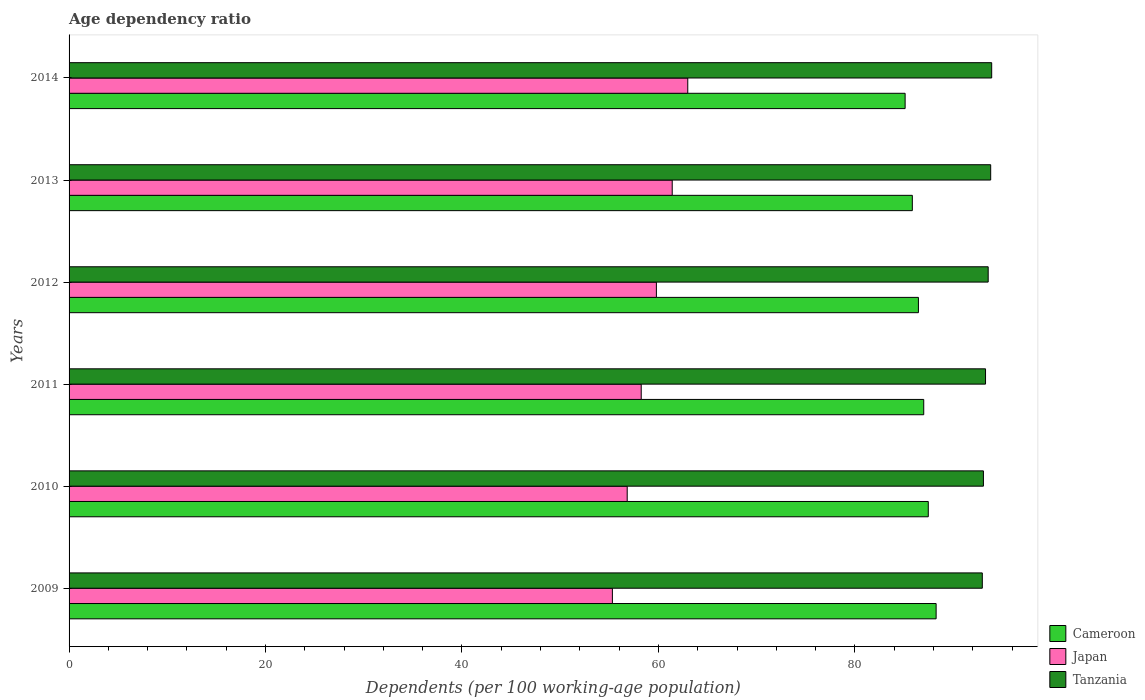How many groups of bars are there?
Offer a very short reply. 6. Are the number of bars per tick equal to the number of legend labels?
Keep it short and to the point. Yes. What is the age dependency ratio in in Cameroon in 2010?
Give a very brief answer. 87.47. Across all years, what is the maximum age dependency ratio in in Cameroon?
Make the answer very short. 88.27. Across all years, what is the minimum age dependency ratio in in Japan?
Ensure brevity in your answer.  55.31. In which year was the age dependency ratio in in Cameroon maximum?
Provide a short and direct response. 2009. What is the total age dependency ratio in in Japan in the graph?
Your response must be concise. 354.55. What is the difference between the age dependency ratio in in Cameroon in 2011 and that in 2012?
Your answer should be very brief. 0.54. What is the difference between the age dependency ratio in in Japan in 2010 and the age dependency ratio in in Cameroon in 2012?
Offer a very short reply. -29.65. What is the average age dependency ratio in in Japan per year?
Offer a terse response. 59.09. In the year 2014, what is the difference between the age dependency ratio in in Cameroon and age dependency ratio in in Japan?
Offer a terse response. 22.13. What is the ratio of the age dependency ratio in in Cameroon in 2009 to that in 2014?
Your answer should be compact. 1.04. Is the difference between the age dependency ratio in in Cameroon in 2012 and 2014 greater than the difference between the age dependency ratio in in Japan in 2012 and 2014?
Provide a short and direct response. Yes. What is the difference between the highest and the second highest age dependency ratio in in Japan?
Provide a short and direct response. 1.58. What is the difference between the highest and the lowest age dependency ratio in in Tanzania?
Give a very brief answer. 0.95. In how many years, is the age dependency ratio in in Japan greater than the average age dependency ratio in in Japan taken over all years?
Ensure brevity in your answer.  3. Is the sum of the age dependency ratio in in Japan in 2009 and 2011 greater than the maximum age dependency ratio in in Cameroon across all years?
Your answer should be compact. Yes. What does the 1st bar from the top in 2009 represents?
Make the answer very short. Tanzania. What does the 3rd bar from the bottom in 2010 represents?
Keep it short and to the point. Tanzania. How many bars are there?
Ensure brevity in your answer.  18. Are all the bars in the graph horizontal?
Provide a succinct answer. Yes. How many years are there in the graph?
Your answer should be very brief. 6. Does the graph contain grids?
Offer a terse response. No. How are the legend labels stacked?
Give a very brief answer. Vertical. What is the title of the graph?
Provide a succinct answer. Age dependency ratio. Does "Finland" appear as one of the legend labels in the graph?
Ensure brevity in your answer.  No. What is the label or title of the X-axis?
Ensure brevity in your answer.  Dependents (per 100 working-age population). What is the Dependents (per 100 working-age population) in Cameroon in 2009?
Offer a terse response. 88.27. What is the Dependents (per 100 working-age population) of Japan in 2009?
Ensure brevity in your answer.  55.31. What is the Dependents (per 100 working-age population) in Tanzania in 2009?
Your answer should be compact. 92.97. What is the Dependents (per 100 working-age population) of Cameroon in 2010?
Your answer should be compact. 87.47. What is the Dependents (per 100 working-age population) of Japan in 2010?
Your response must be concise. 56.82. What is the Dependents (per 100 working-age population) of Tanzania in 2010?
Your response must be concise. 93.08. What is the Dependents (per 100 working-age population) in Cameroon in 2011?
Your response must be concise. 87.01. What is the Dependents (per 100 working-age population) in Japan in 2011?
Provide a succinct answer. 58.24. What is the Dependents (per 100 working-age population) in Tanzania in 2011?
Give a very brief answer. 93.3. What is the Dependents (per 100 working-age population) in Cameroon in 2012?
Your answer should be compact. 86.47. What is the Dependents (per 100 working-age population) in Japan in 2012?
Keep it short and to the point. 59.79. What is the Dependents (per 100 working-age population) in Tanzania in 2012?
Your answer should be very brief. 93.57. What is the Dependents (per 100 working-age population) of Cameroon in 2013?
Keep it short and to the point. 85.84. What is the Dependents (per 100 working-age population) in Japan in 2013?
Provide a short and direct response. 61.4. What is the Dependents (per 100 working-age population) in Tanzania in 2013?
Offer a very short reply. 93.82. What is the Dependents (per 100 working-age population) in Cameroon in 2014?
Provide a succinct answer. 85.11. What is the Dependents (per 100 working-age population) in Japan in 2014?
Make the answer very short. 62.98. What is the Dependents (per 100 working-age population) of Tanzania in 2014?
Provide a succinct answer. 93.92. Across all years, what is the maximum Dependents (per 100 working-age population) in Cameroon?
Offer a terse response. 88.27. Across all years, what is the maximum Dependents (per 100 working-age population) of Japan?
Make the answer very short. 62.98. Across all years, what is the maximum Dependents (per 100 working-age population) in Tanzania?
Your answer should be very brief. 93.92. Across all years, what is the minimum Dependents (per 100 working-age population) of Cameroon?
Your answer should be very brief. 85.11. Across all years, what is the minimum Dependents (per 100 working-age population) in Japan?
Your answer should be compact. 55.31. Across all years, what is the minimum Dependents (per 100 working-age population) of Tanzania?
Your answer should be very brief. 92.97. What is the total Dependents (per 100 working-age population) of Cameroon in the graph?
Offer a very short reply. 520.17. What is the total Dependents (per 100 working-age population) of Japan in the graph?
Offer a very short reply. 354.55. What is the total Dependents (per 100 working-age population) in Tanzania in the graph?
Ensure brevity in your answer.  560.66. What is the difference between the Dependents (per 100 working-age population) of Cameroon in 2009 and that in 2010?
Provide a short and direct response. 0.8. What is the difference between the Dependents (per 100 working-age population) in Japan in 2009 and that in 2010?
Your answer should be very brief. -1.51. What is the difference between the Dependents (per 100 working-age population) of Tanzania in 2009 and that in 2010?
Offer a very short reply. -0.11. What is the difference between the Dependents (per 100 working-age population) of Cameroon in 2009 and that in 2011?
Ensure brevity in your answer.  1.26. What is the difference between the Dependents (per 100 working-age population) of Japan in 2009 and that in 2011?
Give a very brief answer. -2.93. What is the difference between the Dependents (per 100 working-age population) of Tanzania in 2009 and that in 2011?
Keep it short and to the point. -0.33. What is the difference between the Dependents (per 100 working-age population) of Cameroon in 2009 and that in 2012?
Make the answer very short. 1.8. What is the difference between the Dependents (per 100 working-age population) of Japan in 2009 and that in 2012?
Give a very brief answer. -4.48. What is the difference between the Dependents (per 100 working-age population) of Tanzania in 2009 and that in 2012?
Give a very brief answer. -0.6. What is the difference between the Dependents (per 100 working-age population) of Cameroon in 2009 and that in 2013?
Your answer should be compact. 2.42. What is the difference between the Dependents (per 100 working-age population) in Japan in 2009 and that in 2013?
Offer a terse response. -6.09. What is the difference between the Dependents (per 100 working-age population) of Tanzania in 2009 and that in 2013?
Your response must be concise. -0.85. What is the difference between the Dependents (per 100 working-age population) in Cameroon in 2009 and that in 2014?
Ensure brevity in your answer.  3.16. What is the difference between the Dependents (per 100 working-age population) of Japan in 2009 and that in 2014?
Provide a short and direct response. -7.67. What is the difference between the Dependents (per 100 working-age population) in Tanzania in 2009 and that in 2014?
Your answer should be very brief. -0.95. What is the difference between the Dependents (per 100 working-age population) in Cameroon in 2010 and that in 2011?
Provide a short and direct response. 0.46. What is the difference between the Dependents (per 100 working-age population) of Japan in 2010 and that in 2011?
Offer a very short reply. -1.43. What is the difference between the Dependents (per 100 working-age population) in Tanzania in 2010 and that in 2011?
Offer a very short reply. -0.21. What is the difference between the Dependents (per 100 working-age population) of Cameroon in 2010 and that in 2012?
Your answer should be compact. 1. What is the difference between the Dependents (per 100 working-age population) of Japan in 2010 and that in 2012?
Make the answer very short. -2.97. What is the difference between the Dependents (per 100 working-age population) of Tanzania in 2010 and that in 2012?
Make the answer very short. -0.48. What is the difference between the Dependents (per 100 working-age population) in Cameroon in 2010 and that in 2013?
Your response must be concise. 1.62. What is the difference between the Dependents (per 100 working-age population) in Japan in 2010 and that in 2013?
Your answer should be compact. -4.58. What is the difference between the Dependents (per 100 working-age population) in Tanzania in 2010 and that in 2013?
Give a very brief answer. -0.74. What is the difference between the Dependents (per 100 working-age population) of Cameroon in 2010 and that in 2014?
Your response must be concise. 2.36. What is the difference between the Dependents (per 100 working-age population) in Japan in 2010 and that in 2014?
Make the answer very short. -6.17. What is the difference between the Dependents (per 100 working-age population) in Tanzania in 2010 and that in 2014?
Offer a very short reply. -0.84. What is the difference between the Dependents (per 100 working-age population) in Cameroon in 2011 and that in 2012?
Your answer should be very brief. 0.54. What is the difference between the Dependents (per 100 working-age population) of Japan in 2011 and that in 2012?
Your answer should be compact. -1.55. What is the difference between the Dependents (per 100 working-age population) in Tanzania in 2011 and that in 2012?
Offer a very short reply. -0.27. What is the difference between the Dependents (per 100 working-age population) of Cameroon in 2011 and that in 2013?
Offer a very short reply. 1.16. What is the difference between the Dependents (per 100 working-age population) in Japan in 2011 and that in 2013?
Offer a terse response. -3.16. What is the difference between the Dependents (per 100 working-age population) of Tanzania in 2011 and that in 2013?
Ensure brevity in your answer.  -0.53. What is the difference between the Dependents (per 100 working-age population) in Cameroon in 2011 and that in 2014?
Provide a short and direct response. 1.89. What is the difference between the Dependents (per 100 working-age population) in Japan in 2011 and that in 2014?
Give a very brief answer. -4.74. What is the difference between the Dependents (per 100 working-age population) of Tanzania in 2011 and that in 2014?
Offer a terse response. -0.63. What is the difference between the Dependents (per 100 working-age population) of Cameroon in 2012 and that in 2013?
Your answer should be very brief. 0.62. What is the difference between the Dependents (per 100 working-age population) of Japan in 2012 and that in 2013?
Your answer should be compact. -1.61. What is the difference between the Dependents (per 100 working-age population) in Tanzania in 2012 and that in 2013?
Give a very brief answer. -0.25. What is the difference between the Dependents (per 100 working-age population) in Cameroon in 2012 and that in 2014?
Give a very brief answer. 1.35. What is the difference between the Dependents (per 100 working-age population) in Japan in 2012 and that in 2014?
Provide a short and direct response. -3.19. What is the difference between the Dependents (per 100 working-age population) in Tanzania in 2012 and that in 2014?
Provide a short and direct response. -0.36. What is the difference between the Dependents (per 100 working-age population) in Cameroon in 2013 and that in 2014?
Offer a terse response. 0.73. What is the difference between the Dependents (per 100 working-age population) in Japan in 2013 and that in 2014?
Your answer should be very brief. -1.58. What is the difference between the Dependents (per 100 working-age population) of Tanzania in 2013 and that in 2014?
Your response must be concise. -0.1. What is the difference between the Dependents (per 100 working-age population) in Cameroon in 2009 and the Dependents (per 100 working-age population) in Japan in 2010?
Your response must be concise. 31.45. What is the difference between the Dependents (per 100 working-age population) in Cameroon in 2009 and the Dependents (per 100 working-age population) in Tanzania in 2010?
Provide a short and direct response. -4.82. What is the difference between the Dependents (per 100 working-age population) in Japan in 2009 and the Dependents (per 100 working-age population) in Tanzania in 2010?
Provide a short and direct response. -37.77. What is the difference between the Dependents (per 100 working-age population) in Cameroon in 2009 and the Dependents (per 100 working-age population) in Japan in 2011?
Your answer should be very brief. 30.02. What is the difference between the Dependents (per 100 working-age population) in Cameroon in 2009 and the Dependents (per 100 working-age population) in Tanzania in 2011?
Make the answer very short. -5.03. What is the difference between the Dependents (per 100 working-age population) of Japan in 2009 and the Dependents (per 100 working-age population) of Tanzania in 2011?
Your answer should be compact. -37.99. What is the difference between the Dependents (per 100 working-age population) of Cameroon in 2009 and the Dependents (per 100 working-age population) of Japan in 2012?
Keep it short and to the point. 28.48. What is the difference between the Dependents (per 100 working-age population) in Cameroon in 2009 and the Dependents (per 100 working-age population) in Tanzania in 2012?
Provide a short and direct response. -5.3. What is the difference between the Dependents (per 100 working-age population) in Japan in 2009 and the Dependents (per 100 working-age population) in Tanzania in 2012?
Make the answer very short. -38.26. What is the difference between the Dependents (per 100 working-age population) in Cameroon in 2009 and the Dependents (per 100 working-age population) in Japan in 2013?
Give a very brief answer. 26.87. What is the difference between the Dependents (per 100 working-age population) of Cameroon in 2009 and the Dependents (per 100 working-age population) of Tanzania in 2013?
Keep it short and to the point. -5.55. What is the difference between the Dependents (per 100 working-age population) in Japan in 2009 and the Dependents (per 100 working-age population) in Tanzania in 2013?
Provide a short and direct response. -38.51. What is the difference between the Dependents (per 100 working-age population) of Cameroon in 2009 and the Dependents (per 100 working-age population) of Japan in 2014?
Provide a short and direct response. 25.28. What is the difference between the Dependents (per 100 working-age population) in Cameroon in 2009 and the Dependents (per 100 working-age population) in Tanzania in 2014?
Give a very brief answer. -5.66. What is the difference between the Dependents (per 100 working-age population) of Japan in 2009 and the Dependents (per 100 working-age population) of Tanzania in 2014?
Ensure brevity in your answer.  -38.61. What is the difference between the Dependents (per 100 working-age population) in Cameroon in 2010 and the Dependents (per 100 working-age population) in Japan in 2011?
Ensure brevity in your answer.  29.22. What is the difference between the Dependents (per 100 working-age population) in Cameroon in 2010 and the Dependents (per 100 working-age population) in Tanzania in 2011?
Provide a succinct answer. -5.83. What is the difference between the Dependents (per 100 working-age population) of Japan in 2010 and the Dependents (per 100 working-age population) of Tanzania in 2011?
Provide a short and direct response. -36.48. What is the difference between the Dependents (per 100 working-age population) in Cameroon in 2010 and the Dependents (per 100 working-age population) in Japan in 2012?
Make the answer very short. 27.68. What is the difference between the Dependents (per 100 working-age population) of Cameroon in 2010 and the Dependents (per 100 working-age population) of Tanzania in 2012?
Make the answer very short. -6.1. What is the difference between the Dependents (per 100 working-age population) in Japan in 2010 and the Dependents (per 100 working-age population) in Tanzania in 2012?
Offer a terse response. -36.75. What is the difference between the Dependents (per 100 working-age population) of Cameroon in 2010 and the Dependents (per 100 working-age population) of Japan in 2013?
Offer a terse response. 26.07. What is the difference between the Dependents (per 100 working-age population) in Cameroon in 2010 and the Dependents (per 100 working-age population) in Tanzania in 2013?
Offer a very short reply. -6.35. What is the difference between the Dependents (per 100 working-age population) in Japan in 2010 and the Dependents (per 100 working-age population) in Tanzania in 2013?
Your answer should be very brief. -37. What is the difference between the Dependents (per 100 working-age population) of Cameroon in 2010 and the Dependents (per 100 working-age population) of Japan in 2014?
Provide a succinct answer. 24.48. What is the difference between the Dependents (per 100 working-age population) of Cameroon in 2010 and the Dependents (per 100 working-age population) of Tanzania in 2014?
Provide a succinct answer. -6.45. What is the difference between the Dependents (per 100 working-age population) in Japan in 2010 and the Dependents (per 100 working-age population) in Tanzania in 2014?
Your answer should be very brief. -37.11. What is the difference between the Dependents (per 100 working-age population) of Cameroon in 2011 and the Dependents (per 100 working-age population) of Japan in 2012?
Make the answer very short. 27.22. What is the difference between the Dependents (per 100 working-age population) of Cameroon in 2011 and the Dependents (per 100 working-age population) of Tanzania in 2012?
Keep it short and to the point. -6.56. What is the difference between the Dependents (per 100 working-age population) in Japan in 2011 and the Dependents (per 100 working-age population) in Tanzania in 2012?
Your answer should be compact. -35.32. What is the difference between the Dependents (per 100 working-age population) of Cameroon in 2011 and the Dependents (per 100 working-age population) of Japan in 2013?
Provide a short and direct response. 25.61. What is the difference between the Dependents (per 100 working-age population) in Cameroon in 2011 and the Dependents (per 100 working-age population) in Tanzania in 2013?
Your response must be concise. -6.82. What is the difference between the Dependents (per 100 working-age population) in Japan in 2011 and the Dependents (per 100 working-age population) in Tanzania in 2013?
Provide a succinct answer. -35.58. What is the difference between the Dependents (per 100 working-age population) of Cameroon in 2011 and the Dependents (per 100 working-age population) of Japan in 2014?
Make the answer very short. 24.02. What is the difference between the Dependents (per 100 working-age population) in Cameroon in 2011 and the Dependents (per 100 working-age population) in Tanzania in 2014?
Ensure brevity in your answer.  -6.92. What is the difference between the Dependents (per 100 working-age population) of Japan in 2011 and the Dependents (per 100 working-age population) of Tanzania in 2014?
Your answer should be compact. -35.68. What is the difference between the Dependents (per 100 working-age population) of Cameroon in 2012 and the Dependents (per 100 working-age population) of Japan in 2013?
Ensure brevity in your answer.  25.07. What is the difference between the Dependents (per 100 working-age population) of Cameroon in 2012 and the Dependents (per 100 working-age population) of Tanzania in 2013?
Ensure brevity in your answer.  -7.36. What is the difference between the Dependents (per 100 working-age population) in Japan in 2012 and the Dependents (per 100 working-age population) in Tanzania in 2013?
Your answer should be compact. -34.03. What is the difference between the Dependents (per 100 working-age population) of Cameroon in 2012 and the Dependents (per 100 working-age population) of Japan in 2014?
Provide a short and direct response. 23.48. What is the difference between the Dependents (per 100 working-age population) in Cameroon in 2012 and the Dependents (per 100 working-age population) in Tanzania in 2014?
Offer a very short reply. -7.46. What is the difference between the Dependents (per 100 working-age population) of Japan in 2012 and the Dependents (per 100 working-age population) of Tanzania in 2014?
Make the answer very short. -34.13. What is the difference between the Dependents (per 100 working-age population) in Cameroon in 2013 and the Dependents (per 100 working-age population) in Japan in 2014?
Your answer should be very brief. 22.86. What is the difference between the Dependents (per 100 working-age population) in Cameroon in 2013 and the Dependents (per 100 working-age population) in Tanzania in 2014?
Make the answer very short. -8.08. What is the difference between the Dependents (per 100 working-age population) in Japan in 2013 and the Dependents (per 100 working-age population) in Tanzania in 2014?
Your answer should be very brief. -32.52. What is the average Dependents (per 100 working-age population) in Cameroon per year?
Your answer should be compact. 86.69. What is the average Dependents (per 100 working-age population) in Japan per year?
Keep it short and to the point. 59.09. What is the average Dependents (per 100 working-age population) of Tanzania per year?
Give a very brief answer. 93.44. In the year 2009, what is the difference between the Dependents (per 100 working-age population) of Cameroon and Dependents (per 100 working-age population) of Japan?
Your answer should be compact. 32.96. In the year 2009, what is the difference between the Dependents (per 100 working-age population) in Cameroon and Dependents (per 100 working-age population) in Tanzania?
Your response must be concise. -4.7. In the year 2009, what is the difference between the Dependents (per 100 working-age population) of Japan and Dependents (per 100 working-age population) of Tanzania?
Offer a very short reply. -37.66. In the year 2010, what is the difference between the Dependents (per 100 working-age population) of Cameroon and Dependents (per 100 working-age population) of Japan?
Offer a terse response. 30.65. In the year 2010, what is the difference between the Dependents (per 100 working-age population) of Cameroon and Dependents (per 100 working-age population) of Tanzania?
Provide a succinct answer. -5.61. In the year 2010, what is the difference between the Dependents (per 100 working-age population) in Japan and Dependents (per 100 working-age population) in Tanzania?
Keep it short and to the point. -36.26. In the year 2011, what is the difference between the Dependents (per 100 working-age population) of Cameroon and Dependents (per 100 working-age population) of Japan?
Your answer should be very brief. 28.76. In the year 2011, what is the difference between the Dependents (per 100 working-age population) of Cameroon and Dependents (per 100 working-age population) of Tanzania?
Your response must be concise. -6.29. In the year 2011, what is the difference between the Dependents (per 100 working-age population) of Japan and Dependents (per 100 working-age population) of Tanzania?
Offer a terse response. -35.05. In the year 2012, what is the difference between the Dependents (per 100 working-age population) in Cameroon and Dependents (per 100 working-age population) in Japan?
Ensure brevity in your answer.  26.68. In the year 2012, what is the difference between the Dependents (per 100 working-age population) in Cameroon and Dependents (per 100 working-age population) in Tanzania?
Your response must be concise. -7.1. In the year 2012, what is the difference between the Dependents (per 100 working-age population) of Japan and Dependents (per 100 working-age population) of Tanzania?
Your response must be concise. -33.78. In the year 2013, what is the difference between the Dependents (per 100 working-age population) in Cameroon and Dependents (per 100 working-age population) in Japan?
Make the answer very short. 24.44. In the year 2013, what is the difference between the Dependents (per 100 working-age population) of Cameroon and Dependents (per 100 working-age population) of Tanzania?
Give a very brief answer. -7.98. In the year 2013, what is the difference between the Dependents (per 100 working-age population) of Japan and Dependents (per 100 working-age population) of Tanzania?
Provide a succinct answer. -32.42. In the year 2014, what is the difference between the Dependents (per 100 working-age population) of Cameroon and Dependents (per 100 working-age population) of Japan?
Ensure brevity in your answer.  22.13. In the year 2014, what is the difference between the Dependents (per 100 working-age population) of Cameroon and Dependents (per 100 working-age population) of Tanzania?
Offer a terse response. -8.81. In the year 2014, what is the difference between the Dependents (per 100 working-age population) in Japan and Dependents (per 100 working-age population) in Tanzania?
Ensure brevity in your answer.  -30.94. What is the ratio of the Dependents (per 100 working-age population) in Cameroon in 2009 to that in 2010?
Offer a very short reply. 1.01. What is the ratio of the Dependents (per 100 working-age population) of Japan in 2009 to that in 2010?
Keep it short and to the point. 0.97. What is the ratio of the Dependents (per 100 working-age population) in Tanzania in 2009 to that in 2010?
Provide a short and direct response. 1. What is the ratio of the Dependents (per 100 working-age population) of Cameroon in 2009 to that in 2011?
Make the answer very short. 1.01. What is the ratio of the Dependents (per 100 working-age population) in Japan in 2009 to that in 2011?
Make the answer very short. 0.95. What is the ratio of the Dependents (per 100 working-age population) of Tanzania in 2009 to that in 2011?
Your answer should be compact. 1. What is the ratio of the Dependents (per 100 working-age population) in Cameroon in 2009 to that in 2012?
Offer a very short reply. 1.02. What is the ratio of the Dependents (per 100 working-age population) in Japan in 2009 to that in 2012?
Offer a very short reply. 0.93. What is the ratio of the Dependents (per 100 working-age population) of Tanzania in 2009 to that in 2012?
Your response must be concise. 0.99. What is the ratio of the Dependents (per 100 working-age population) of Cameroon in 2009 to that in 2013?
Offer a very short reply. 1.03. What is the ratio of the Dependents (per 100 working-age population) of Japan in 2009 to that in 2013?
Your answer should be compact. 0.9. What is the ratio of the Dependents (per 100 working-age population) of Tanzania in 2009 to that in 2013?
Provide a succinct answer. 0.99. What is the ratio of the Dependents (per 100 working-age population) in Cameroon in 2009 to that in 2014?
Your answer should be very brief. 1.04. What is the ratio of the Dependents (per 100 working-age population) of Japan in 2009 to that in 2014?
Your response must be concise. 0.88. What is the ratio of the Dependents (per 100 working-age population) of Cameroon in 2010 to that in 2011?
Provide a succinct answer. 1.01. What is the ratio of the Dependents (per 100 working-age population) in Japan in 2010 to that in 2011?
Your answer should be very brief. 0.98. What is the ratio of the Dependents (per 100 working-age population) of Cameroon in 2010 to that in 2012?
Your response must be concise. 1.01. What is the ratio of the Dependents (per 100 working-age population) of Japan in 2010 to that in 2012?
Your response must be concise. 0.95. What is the ratio of the Dependents (per 100 working-age population) of Cameroon in 2010 to that in 2013?
Give a very brief answer. 1.02. What is the ratio of the Dependents (per 100 working-age population) of Japan in 2010 to that in 2013?
Provide a succinct answer. 0.93. What is the ratio of the Dependents (per 100 working-age population) in Cameroon in 2010 to that in 2014?
Keep it short and to the point. 1.03. What is the ratio of the Dependents (per 100 working-age population) in Japan in 2010 to that in 2014?
Provide a short and direct response. 0.9. What is the ratio of the Dependents (per 100 working-age population) in Japan in 2011 to that in 2012?
Provide a short and direct response. 0.97. What is the ratio of the Dependents (per 100 working-age population) in Tanzania in 2011 to that in 2012?
Ensure brevity in your answer.  1. What is the ratio of the Dependents (per 100 working-age population) in Cameroon in 2011 to that in 2013?
Provide a short and direct response. 1.01. What is the ratio of the Dependents (per 100 working-age population) of Japan in 2011 to that in 2013?
Offer a very short reply. 0.95. What is the ratio of the Dependents (per 100 working-age population) of Tanzania in 2011 to that in 2013?
Keep it short and to the point. 0.99. What is the ratio of the Dependents (per 100 working-age population) in Cameroon in 2011 to that in 2014?
Your answer should be compact. 1.02. What is the ratio of the Dependents (per 100 working-age population) of Japan in 2011 to that in 2014?
Provide a succinct answer. 0.92. What is the ratio of the Dependents (per 100 working-age population) in Japan in 2012 to that in 2013?
Your answer should be very brief. 0.97. What is the ratio of the Dependents (per 100 working-age population) in Tanzania in 2012 to that in 2013?
Ensure brevity in your answer.  1. What is the ratio of the Dependents (per 100 working-age population) of Cameroon in 2012 to that in 2014?
Offer a very short reply. 1.02. What is the ratio of the Dependents (per 100 working-age population) in Japan in 2012 to that in 2014?
Offer a terse response. 0.95. What is the ratio of the Dependents (per 100 working-age population) in Tanzania in 2012 to that in 2014?
Ensure brevity in your answer.  1. What is the ratio of the Dependents (per 100 working-age population) in Cameroon in 2013 to that in 2014?
Provide a short and direct response. 1.01. What is the ratio of the Dependents (per 100 working-age population) in Japan in 2013 to that in 2014?
Offer a terse response. 0.97. What is the difference between the highest and the second highest Dependents (per 100 working-age population) of Cameroon?
Make the answer very short. 0.8. What is the difference between the highest and the second highest Dependents (per 100 working-age population) in Japan?
Provide a succinct answer. 1.58. What is the difference between the highest and the second highest Dependents (per 100 working-age population) in Tanzania?
Your response must be concise. 0.1. What is the difference between the highest and the lowest Dependents (per 100 working-age population) of Cameroon?
Offer a very short reply. 3.16. What is the difference between the highest and the lowest Dependents (per 100 working-age population) of Japan?
Your answer should be very brief. 7.67. What is the difference between the highest and the lowest Dependents (per 100 working-age population) of Tanzania?
Offer a very short reply. 0.95. 